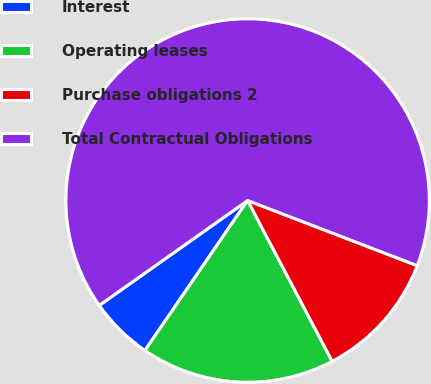<chart> <loc_0><loc_0><loc_500><loc_500><pie_chart><fcel>Interest<fcel>Operating leases<fcel>Purchase obligations 2<fcel>Total Contractual Obligations<nl><fcel>5.65%<fcel>17.26%<fcel>11.46%<fcel>65.63%<nl></chart> 